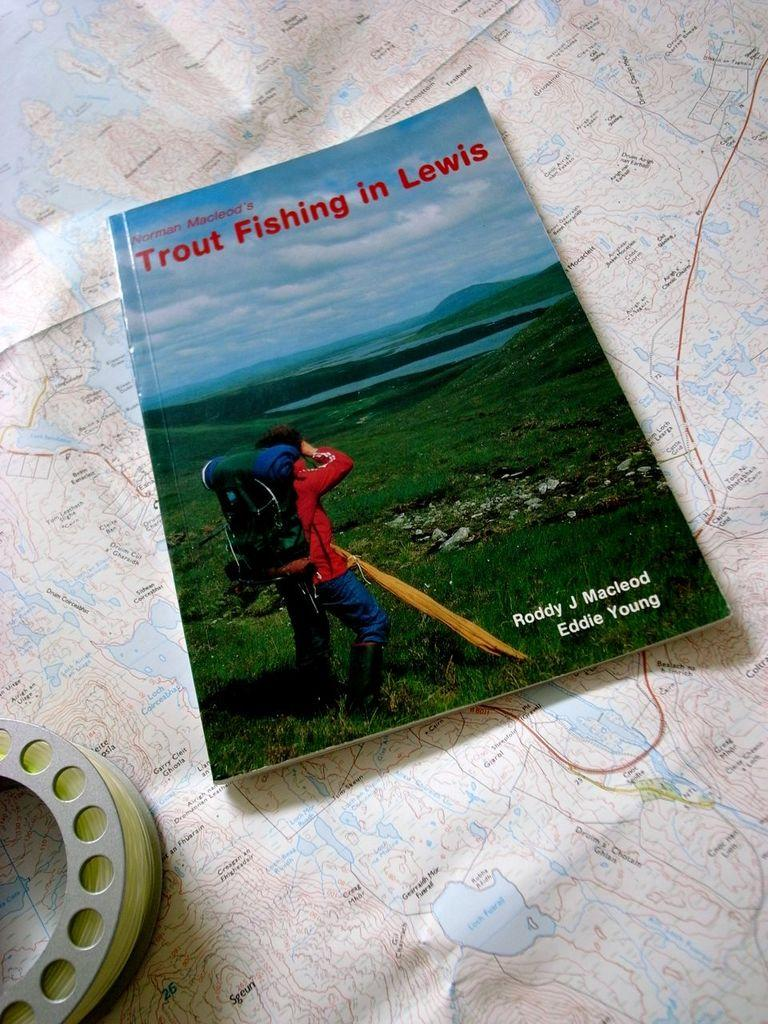<image>
Relay a brief, clear account of the picture shown. A book called Trout Fishing in Lewis by Norman Macleod sits on top of a map next to a fishing reel 